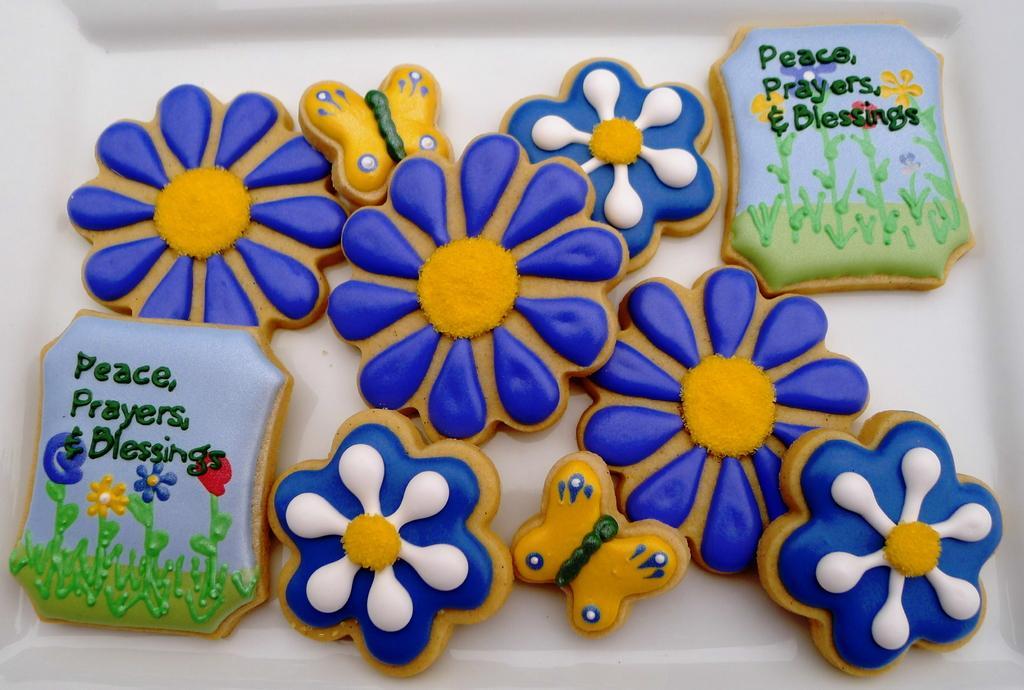Can you describe this image briefly? As we can see in the image there are plastic blue color flowers, yellow color butterflies and there is something written. 